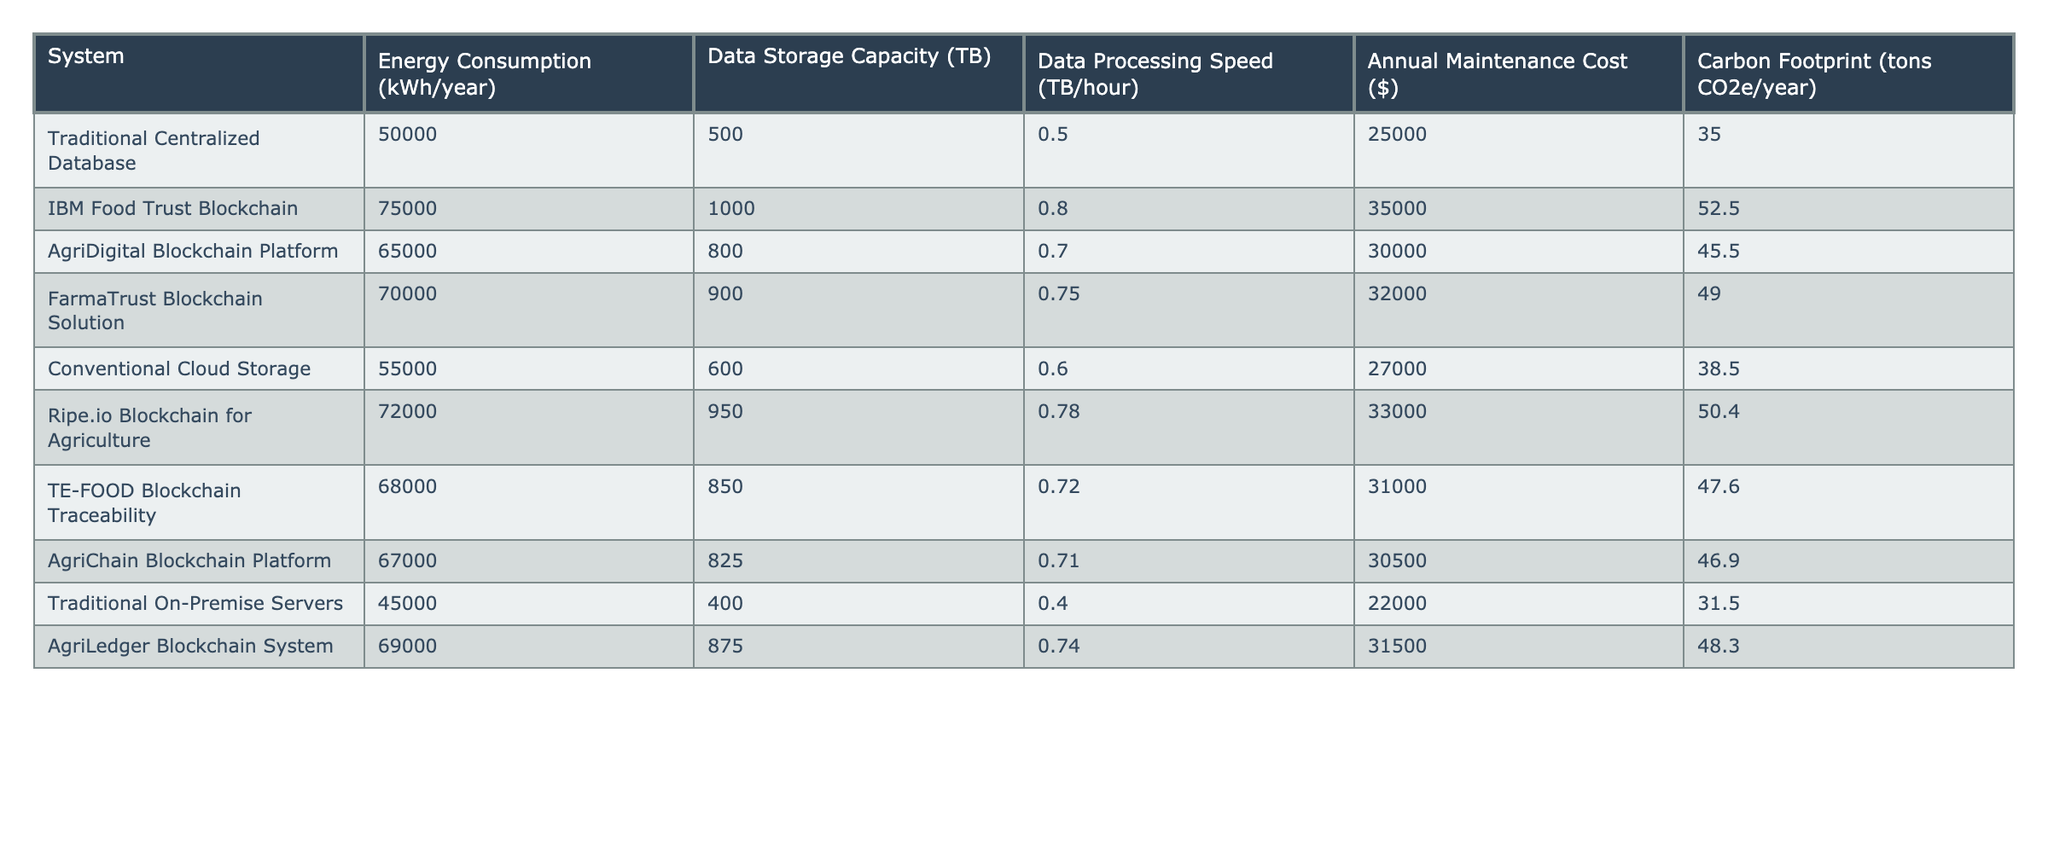What is the energy consumption of the Traditional Centralized Database? The energy consumption value for the Traditional Centralized Database can be found directly in the table, which shows it as 50,000 kWh/year.
Answer: 50,000 kWh/year Which blockchain system has the highest carbon footprint? Looking at the carbon footprint values in the table, IBM Food Trust Blockchain has the highest value at 52.5 tons CO2e/year.
Answer: IBM Food Trust Blockchain How much more energy does the IBM Food Trust Blockchain consume compared to Traditional On-Premise Servers? The IBM Food Trust Blockchain consumes 75,000 kWh/year while Traditional On-Premise Servers consume 45,000 kWh/year. The difference is 75,000 - 45,000 = 30,000 kWh/year.
Answer: 30,000 kWh/year What is the average energy consumption of all the blockchain systems listed? To find the average, add the energy consumption of each blockchain system: 75,000 + 65,000 + 70,000 + 72,000 + 68,000 + 67,000 + 69,000 = 486,000 kWh/year. There are 7 systems, so the average is 486,000 / 7 = 69,428.57, rounded to 69,429 kWh/year.
Answer: 69,429 kWh/year Is the energy consumption of Ripe.io Blockchain for Agriculture higher than AgriLedger Blockchain System? The Ripe.io Blockchain for Agriculture consumes 72,000 kWh/year and the AgriLedger Blockchain System consumes 69,000 kWh/year. Since 72,000 > 69,000, the statement is true.
Answer: Yes What is the total annual maintenance cost of all traditional systems compared to all blockchain systems? The total annual maintenance cost for traditional systems (Traditional Centralized Database, Conventional Cloud Storage, Traditional On-Premise Servers) is 25,000 + 27,000 + 22,000 = 74,000 dollars. The total for blockchain systems (IBM Food Trust, AgriDigital, FarmaTrust, Ripe.io, TE-FOOD, AgriChain, AgriLedger) is 35,000 + 30,000 + 32,000 + 33,000 + 31,000 + 30,500 + 31,500 = 292,000 dollars. Therefore, traditional systems cost 74,000 and blockchain systems cost 292,000.
Answer: Traditional: 74,000 dollars; Blockchain: 292,000 dollars Which system offers the highest data storage capacity? In the table, the system with the highest data storage capacity is the IBM Food Trust Blockchain with 1,000 TB.
Answer: IBM Food Trust Blockchain What is the difference in data processing speed between the Traditional Centralized Database and the AgriDigital Blockchain Platform? The Traditional Centralized Database has a data processing speed of 0.5 TB/hour, while the AgriDigital Blockchain Platform has a speed of 0.7 TB/hour. The difference is 0.7 - 0.5 = 0.2 TB/hour.
Answer: 0.2 TB/hour What is the median annual maintenance cost among all systems listed? To find the median, sort all the maintenance costs: [22,000, 25,000, 27,000, 30,000, 30,500, 31,000, 31,500, 32,000, 33,000, 35,000]. With 10 values, the median is the average of the 5th and 6th values, which are 30,500 and 31,000. The median is (30,500 + 31,000) / 2 = 30,750 dollars.
Answer: 30,750 dollars Is the Energy Consumption of Conventional Cloud Storage less than the average consumption of the blockchain platforms? Conventional Cloud Storage consumes 55,000 kWh/year. Calculate the average of the blockchain platforms’ consumption: 486,000 / 7 ≈ 69,429 kWh/year. Since 55,000 < 69,429, the answer is true.
Answer: Yes 